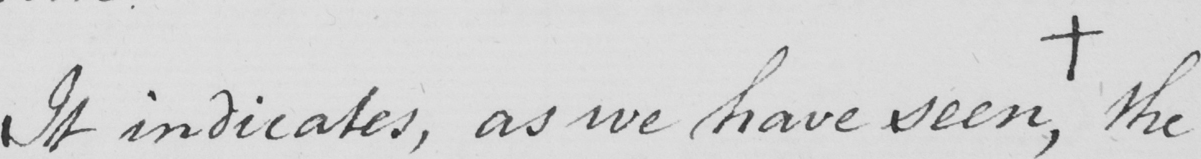What text is written in this handwritten line? It indicates , as we have seen ,  +  the 